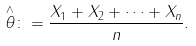Convert formula to latex. <formula><loc_0><loc_0><loc_500><loc_500>\overset { \wedge } { \theta } \colon = \frac { X _ { 1 } + X _ { 2 } + \cdots + X _ { n } } { n } .</formula> 